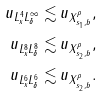<formula> <loc_0><loc_0><loc_500><loc_500>\| u \| _ { L _ { x } ^ { 4 } L _ { \delta } ^ { \infty } } \lesssim & \, \| u \| _ { X _ { s _ { 1 } , b } ^ { \rho } } , \\ \| u \| _ { L _ { x } ^ { 8 } L _ { \delta } ^ { 8 } } \lesssim & \, \| u \| _ { X _ { s _ { 2 } , b } ^ { \rho } } , \\ \| u \| _ { L _ { x } ^ { 6 } L _ { \delta } ^ { 6 } } \lesssim & \, \| u \| _ { X _ { s _ { 2 } , b } ^ { \rho } } .</formula> 